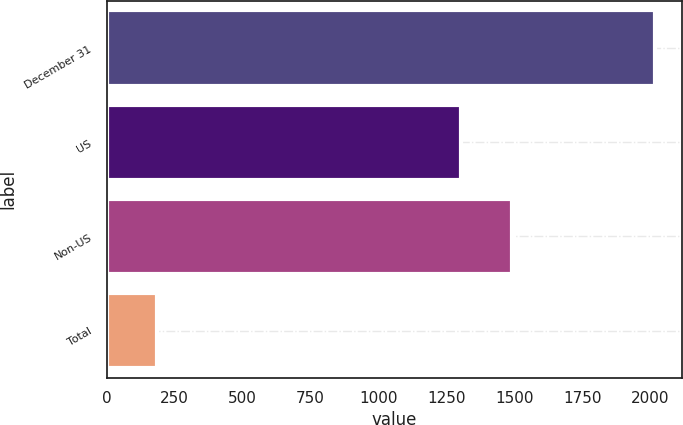Convert chart to OTSL. <chart><loc_0><loc_0><loc_500><loc_500><bar_chart><fcel>December 31<fcel>US<fcel>Non-US<fcel>Total<nl><fcel>2016<fcel>1305<fcel>1492<fcel>187<nl></chart> 